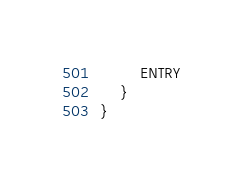Convert code to text. <code><loc_0><loc_0><loc_500><loc_500><_Kotlin_>        ENTRY
    }
}
</code> 